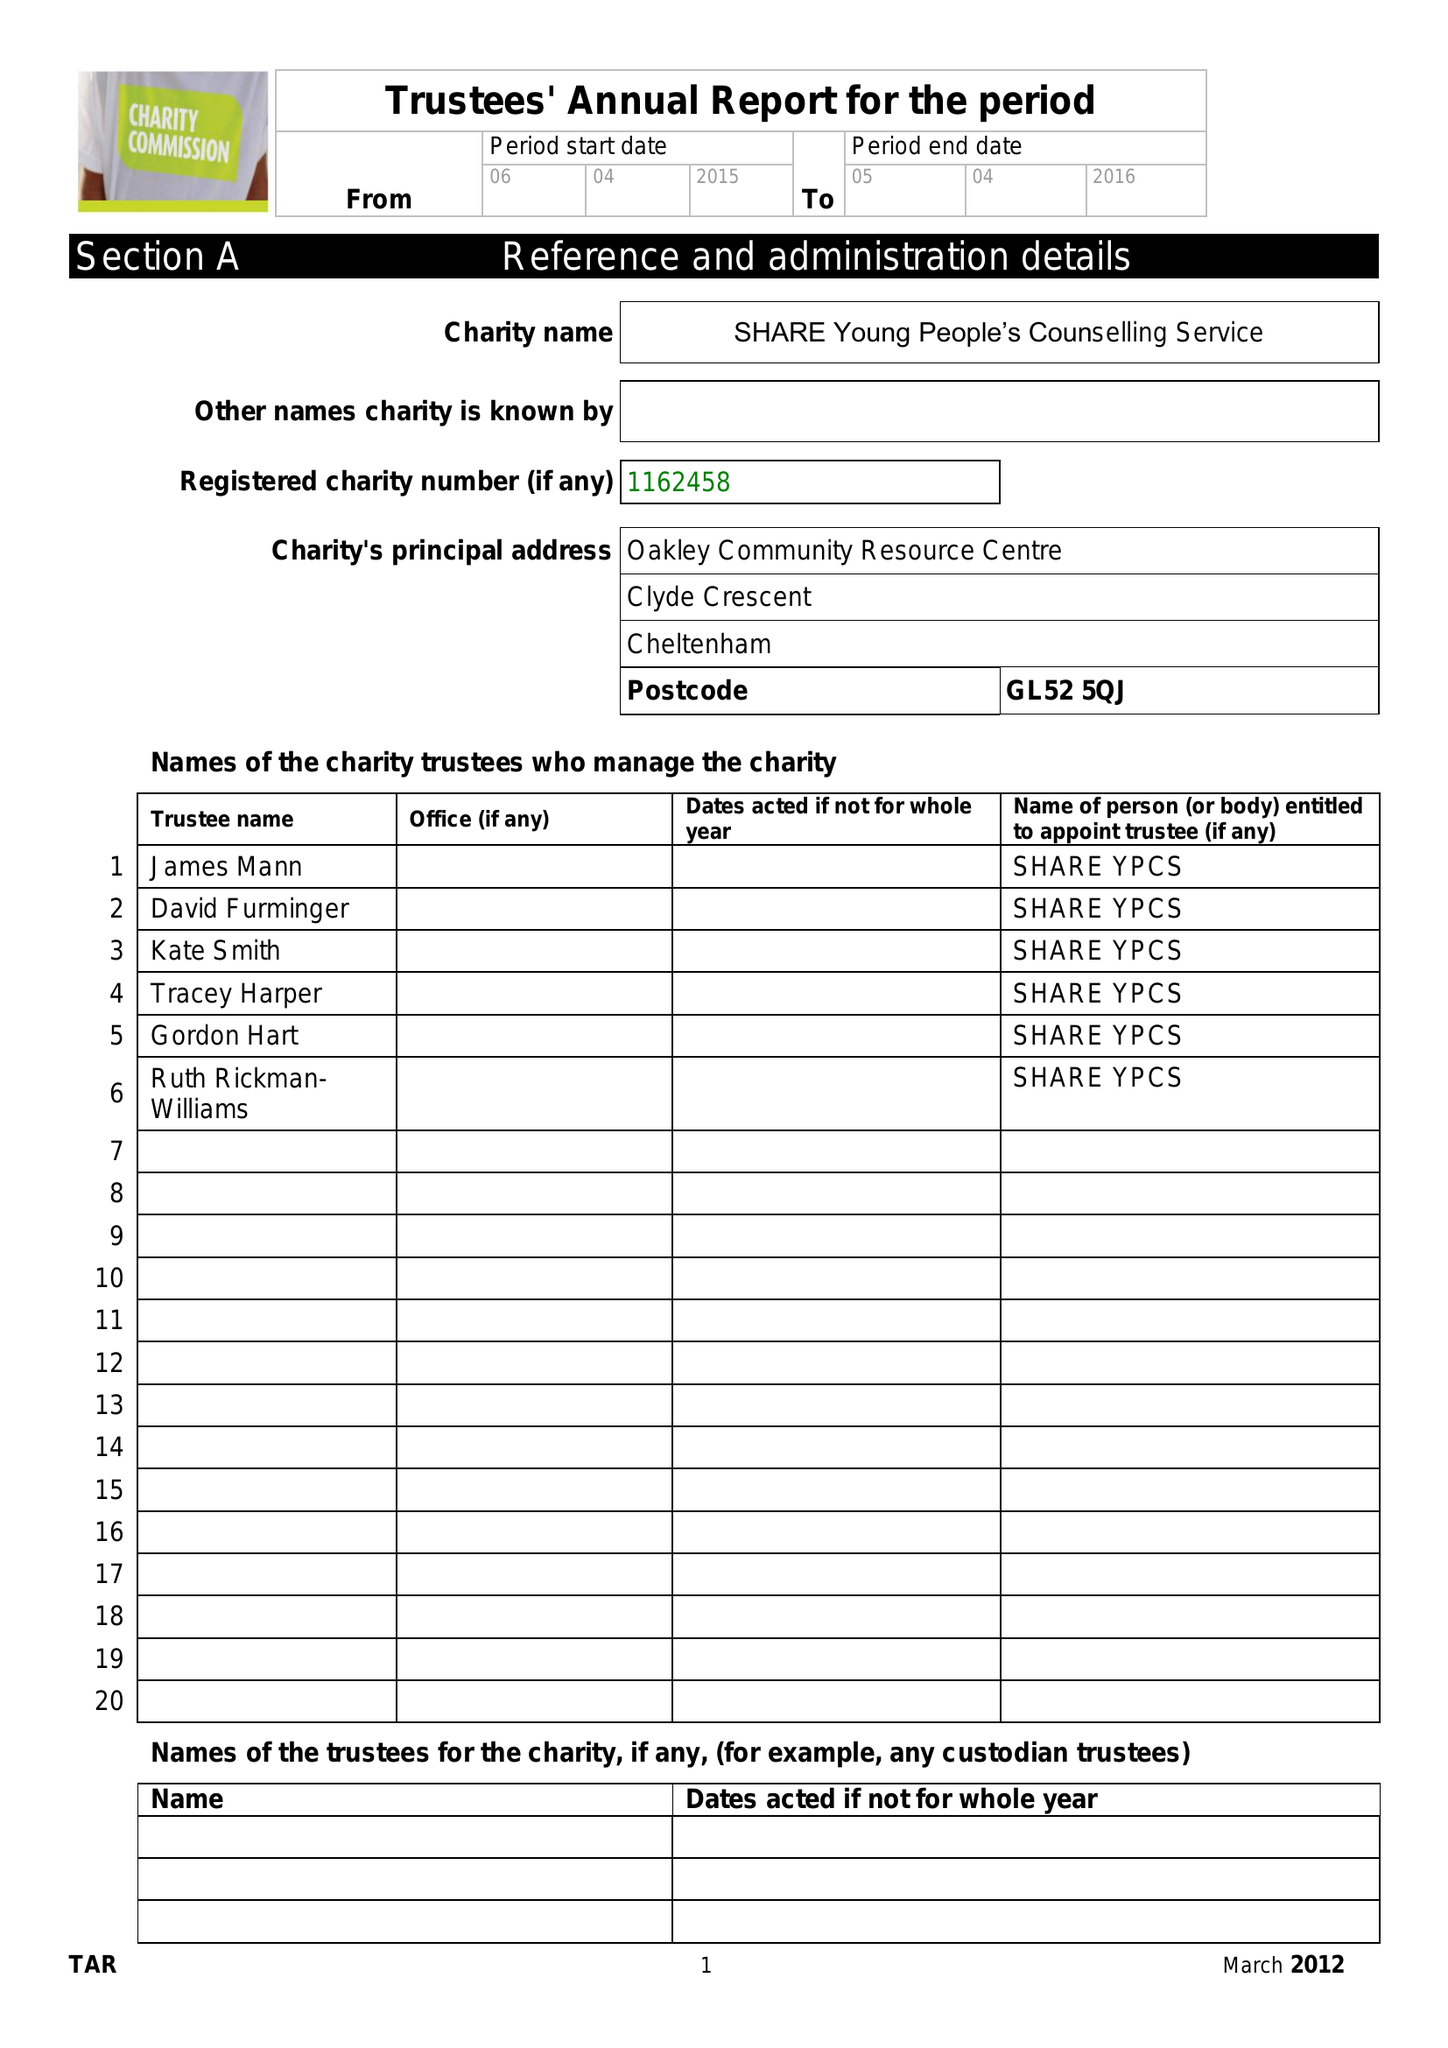What is the value for the address__postcode?
Answer the question using a single word or phrase. GL52 5QJ 